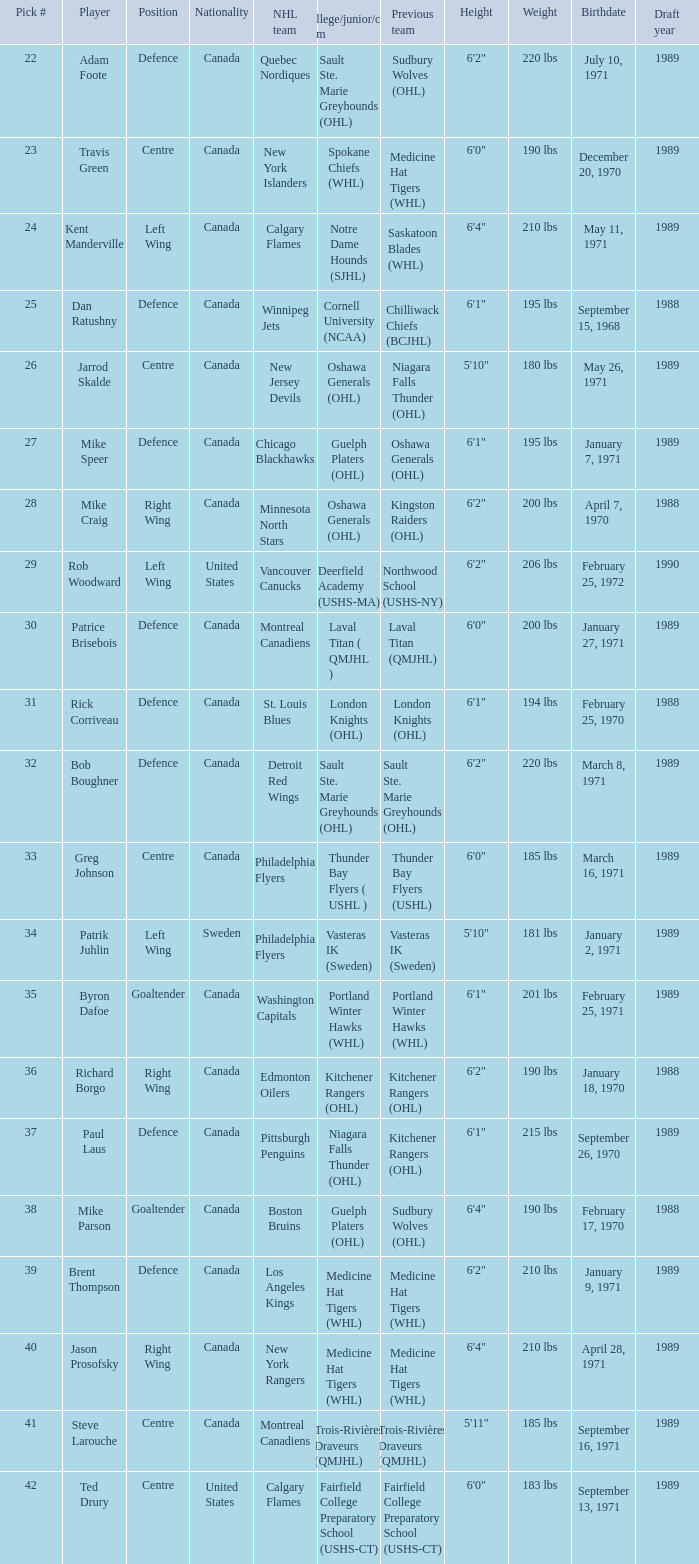Write the full table. {'header': ['Pick #', 'Player', 'Position', 'Nationality', 'NHL team', 'College/junior/club team', 'Previous team', 'Height', 'Weight', 'Birthdate', 'Draft year'], 'rows': [['22', 'Adam Foote', 'Defence', 'Canada', 'Quebec Nordiques', 'Sault Ste. Marie Greyhounds (OHL)', 'Sudbury Wolves (OHL)', '6\'2"', '220 lbs', 'July 10, 1971', '1989'], ['23', 'Travis Green', 'Centre', 'Canada', 'New York Islanders', 'Spokane Chiefs (WHL)', 'Medicine Hat Tigers (WHL)', '6\'0"', '190 lbs', 'December 20, 1970', '1989'], ['24', 'Kent Manderville', 'Left Wing', 'Canada', 'Calgary Flames', 'Notre Dame Hounds (SJHL)', 'Saskatoon Blades (WHL)', '6\'4"', '210 lbs', 'May 11, 1971', '1989'], ['25', 'Dan Ratushny', 'Defence', 'Canada', 'Winnipeg Jets', 'Cornell University (NCAA)', 'Chilliwack Chiefs (BCJHL)', '6\'1"', '195 lbs', 'September 15, 1968', '1988'], ['26', 'Jarrod Skalde', 'Centre', 'Canada', 'New Jersey Devils', 'Oshawa Generals (OHL)', 'Niagara Falls Thunder (OHL)', '5\'10"', '180 lbs', 'May 26, 1971', '1989'], ['27', 'Mike Speer', 'Defence', 'Canada', 'Chicago Blackhawks', 'Guelph Platers (OHL)', 'Oshawa Generals (OHL)', '6\'1"', '195 lbs', 'January 7, 1971', '1989'], ['28', 'Mike Craig', 'Right Wing', 'Canada', 'Minnesota North Stars', 'Oshawa Generals (OHL)', 'Kingston Raiders (OHL)', '6\'2"', '200 lbs', 'April 7, 1970', '1988'], ['29', 'Rob Woodward', 'Left Wing', 'United States', 'Vancouver Canucks', 'Deerfield Academy (USHS-MA)', 'Northwood School (USHS-NY)', '6\'2"', '206 lbs', 'February 25, 1972', '1990'], ['30', 'Patrice Brisebois', 'Defence', 'Canada', 'Montreal Canadiens', 'Laval Titan ( QMJHL )', 'Laval Titan (QMJHL)', '6\'0"', '200 lbs', 'January 27, 1971', '1989'], ['31', 'Rick Corriveau', 'Defence', 'Canada', 'St. Louis Blues', 'London Knights (OHL)', 'London Knights (OHL)', '6\'1"', '194 lbs', 'February 25, 1970', '1988'], ['32', 'Bob Boughner', 'Defence', 'Canada', 'Detroit Red Wings', 'Sault Ste. Marie Greyhounds (OHL)', 'Sault Ste. Marie Greyhounds (OHL)', '6\'2"', '220 lbs', 'March 8, 1971', '1989'], ['33', 'Greg Johnson', 'Centre', 'Canada', 'Philadelphia Flyers', 'Thunder Bay Flyers ( USHL )', 'Thunder Bay Flyers (USHL)', '6\'0"', '185 lbs', 'March 16, 1971', '1989'], ['34', 'Patrik Juhlin', 'Left Wing', 'Sweden', 'Philadelphia Flyers', 'Vasteras IK (Sweden)', 'Vasteras IK (Sweden)', '5\'10"', '181 lbs', 'January 2, 1971', '1989'], ['35', 'Byron Dafoe', 'Goaltender', 'Canada', 'Washington Capitals', 'Portland Winter Hawks (WHL)', 'Portland Winter Hawks (WHL)', '6\'1"', '201 lbs', 'February 25, 1971', '1989'], ['36', 'Richard Borgo', 'Right Wing', 'Canada', 'Edmonton Oilers', 'Kitchener Rangers (OHL)', 'Kitchener Rangers (OHL)', '6\'2"', '190 lbs', 'January 18, 1970', '1988'], ['37', 'Paul Laus', 'Defence', 'Canada', 'Pittsburgh Penguins', 'Niagara Falls Thunder (OHL)', 'Kitchener Rangers (OHL)', '6\'1"', '215 lbs', 'September 26, 1970', '1989'], ['38', 'Mike Parson', 'Goaltender', 'Canada', 'Boston Bruins', 'Guelph Platers (OHL)', 'Sudbury Wolves (OHL)', '6\'4"', '190 lbs', 'February 17, 1970', '1988'], ['39', 'Brent Thompson', 'Defence', 'Canada', 'Los Angeles Kings', 'Medicine Hat Tigers (WHL)', 'Medicine Hat Tigers (WHL)', '6\'2"', '210 lbs', 'January 9, 1971', '1989'], ['40', 'Jason Prosofsky', 'Right Wing', 'Canada', 'New York Rangers', 'Medicine Hat Tigers (WHL)', 'Medicine Hat Tigers (WHL)', '6\'4"', '210 lbs', 'April 28, 1971', '1989'], ['41', 'Steve Larouche', 'Centre', 'Canada', 'Montreal Canadiens', 'Trois-Rivières Draveurs (QMJHL)', 'Trois-Rivières Draveurs (QMJHL)', '5\'11"', '185 lbs', 'September 16, 1971', '1989'], ['42', 'Ted Drury', 'Centre', 'United States', 'Calgary Flames', 'Fairfield College Preparatory School (USHS-CT)', 'Fairfield College Preparatory School (USHS-CT)', '6\'0"', '183 lbs', 'September 13, 1971', '1989']]} What is the nationality of the player picked to go to Washington Capitals? Canada. 